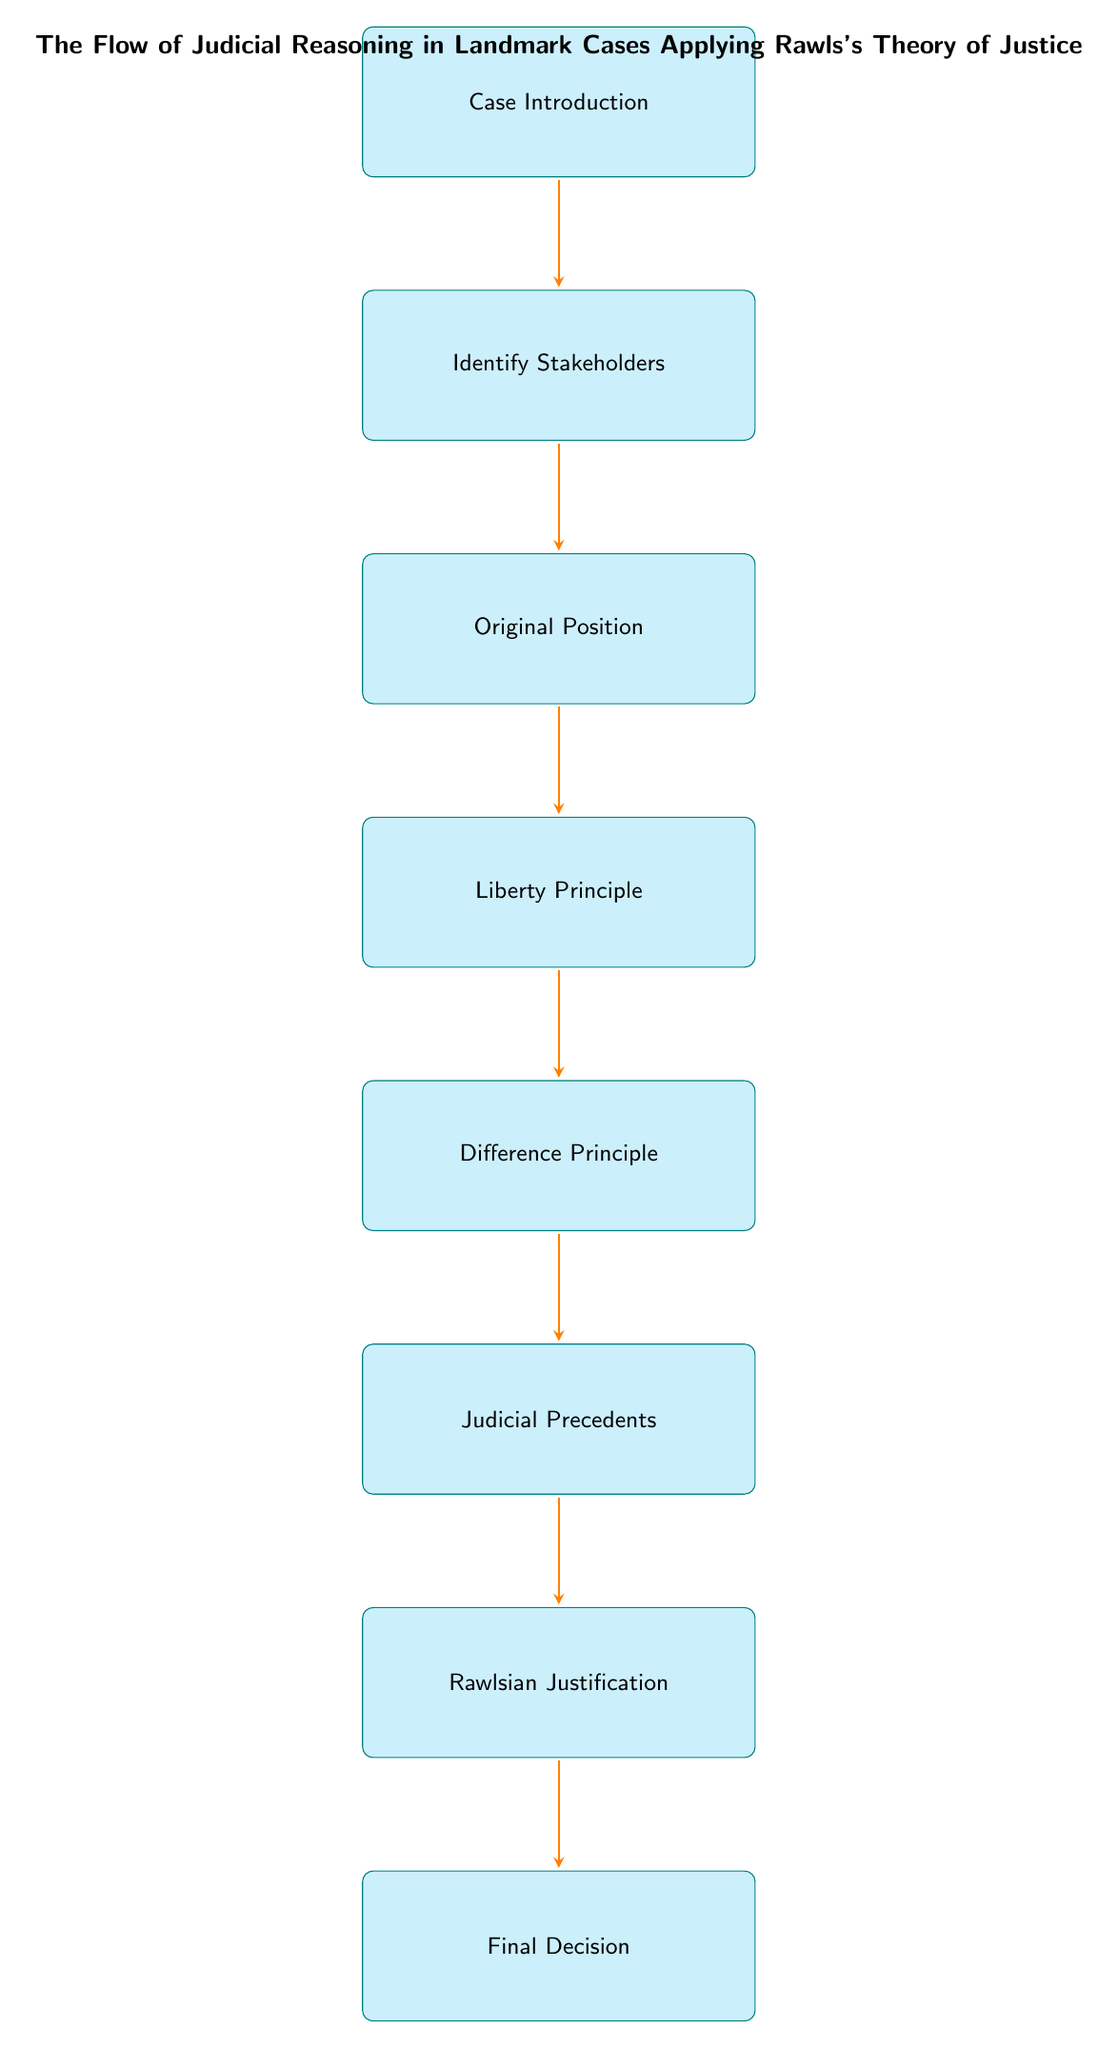What is the first node in the diagram? The first node listed in the diagram is "Case Introduction." It is the initial step in the flow of judicial reasoning.
Answer: Case Introduction How many nodes are present in the diagram? By counting each distinct step included in the diagram, there are eight nodes total that represent different parts of the judicial reasoning process.
Answer: 8 What is the last step in the flow chart? The last step in the flow chart is referred to as "Final Decision." This is where the outcome of the case is stated.
Answer: Final Decision Which node comes after "Difference Principle"? The node that follows "Difference Principle" is "Judicial Precedents." This indicates the sequence in the reasoning process.
Answer: Judicial Precedents What is the purpose of the "Original Position" node? The "Original Position" node outlines how the case should be evaluated under Rawls's 'Veil of Ignorance' concept, regarding impartiality in decision-making.
Answer: To evaluate under 'Veil of Ignorance' Explain the relationship between "Judicial Precedents" and "Rawlsian Justification." "Judicial Precedents" reviews previous related cases influencing the decision, which in turn supports the "Rawlsian Justification" providing an ethical rationale based on Rawls's principles.
Answer: Judicial precedents influence Rawlsian justification How does the "Liberty Principle" assess equality? The "Liberty Principle" examines whether the case maintains equal basic liberties for all individuals, specifically questioning if rights are upheld in the context of the case.
Answer: It assesses basic liberties and equality What is the significance of the "Difference Principle" in relation to stakeholders? The "Difference Principle" analyzes if any inequalities benefit the least advantaged party, which is critical in understanding the impact of a case on stakeholders like the plaintiffs and defendants.
Answer: It analyzes benefits for the least advantaged party 